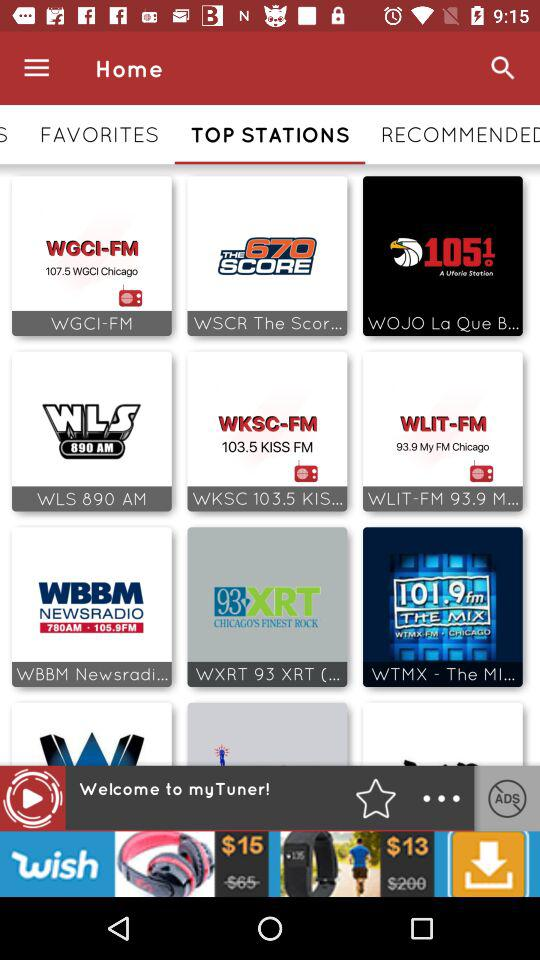What is the name of the application? The name of the applicaton is "myTuner!". 